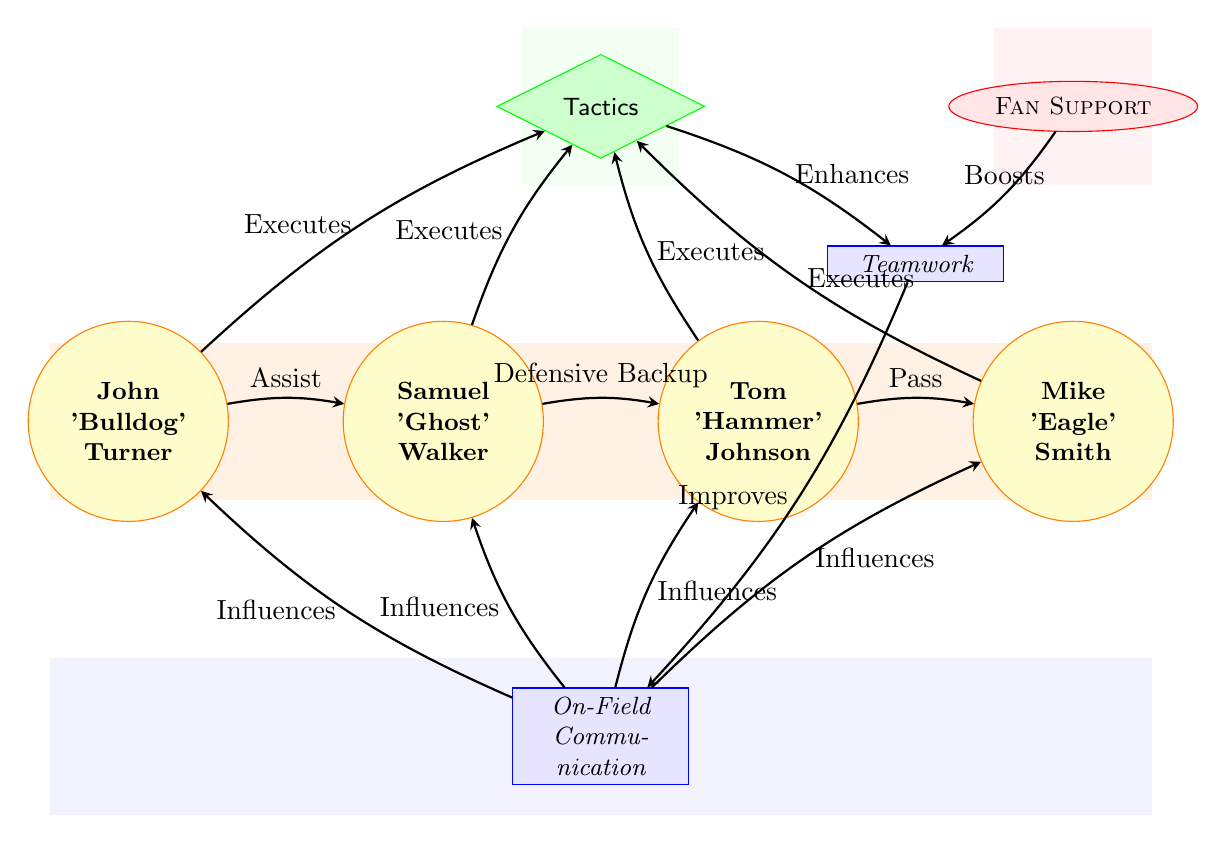What's the total number of nodes in the diagram? The nodes in the diagram include four players, one tactic, two factors, and one external influence. Counting these, there are a total of eight distinct nodes.
Answer: 8 Who is listed as the goalkeeper in the diagram? Reviewing the player nodes, Mike 'Eagle' Smith is identified as the goalkeeper, as he is labeled as such under his name.
Answer: Mike 'Eagle' Smith What is the relationship between player 2 and player 3? The diagram shows an edge labeled "Defensive Backup" originating from player 2 (Samuel 'Ghost' Walker) and pointing towards player 3 (Tom 'Hammer' Johnson). This signifies that player 2 provides backup support to player 3 in defense.
Answer: Defensive Backup Which node enhances teamwork? The diagram indicates that the "Tactics" node has an edge labeled "Enhances," connecting it to the "Teamwork" node, meaning that the execution of tactics boosts the overall teamwork among the players.
Answer: Tactics How many edges are there in the diagram? Each connection between two nodes is represented as an edge. By counting all connections, we find that there are twelve edges in total, linking the players to each other and to the factors or strategy nodes.
Answer: 12 What does "Fan Support" influence in the diagram? The edge labeled "Boosts" indicates that "Fan Support" positively affects "Teamwork." This means that having fans' support contributes to better teamwork on the field.
Answer: Teamwork Which player influences "On-Field Communication"? The diagram indicates there are edges labeled "Influences" that connect all players (players 1, 2, 3, and 4) to the "On-Field Communication" node, meaning every player impacts how the communication happens on the field.
Answer: All players What connects "Teamwork" to "On-Field Communication"? The diagram shows an edge labeled "Improves" that connects "Teamwork" to "On-Field Communication," implying that improving teamwork leads to better communication among players.
Answer: Improves 